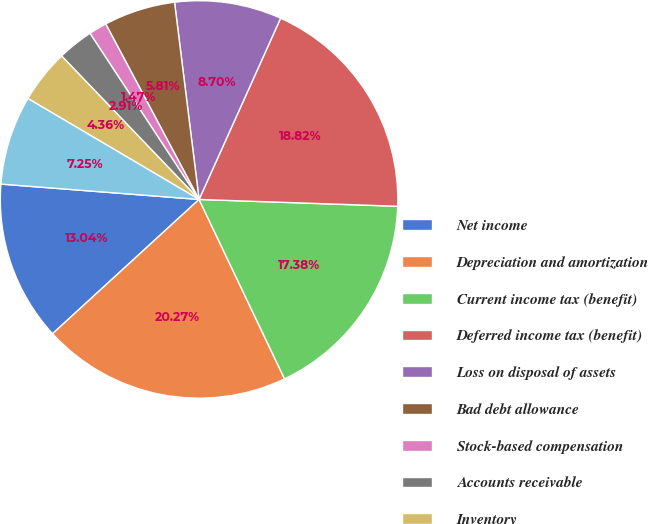Convert chart to OTSL. <chart><loc_0><loc_0><loc_500><loc_500><pie_chart><fcel>Net income<fcel>Depreciation and amortization<fcel>Current income tax (benefit)<fcel>Deferred income tax (benefit)<fcel>Loss on disposal of assets<fcel>Bad debt allowance<fcel>Stock-based compensation<fcel>Accounts receivable<fcel>Inventory<fcel>Prepaid expenses<nl><fcel>13.04%<fcel>20.27%<fcel>17.38%<fcel>18.82%<fcel>8.7%<fcel>5.81%<fcel>1.47%<fcel>2.91%<fcel>4.36%<fcel>7.25%<nl></chart> 